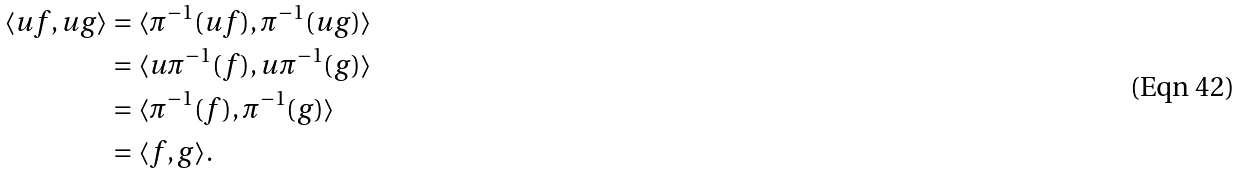Convert formula to latex. <formula><loc_0><loc_0><loc_500><loc_500>\langle u f , u g \rangle & = \langle \pi ^ { - 1 } ( u f ) , \pi ^ { - 1 } ( u g ) \rangle \\ & = \langle u \pi ^ { - 1 } ( f ) , u \pi ^ { - 1 } ( g ) \rangle \\ & = \langle \pi ^ { - 1 } ( f ) , \pi ^ { - 1 } ( g ) \rangle \\ & = \langle f , g \rangle .</formula> 